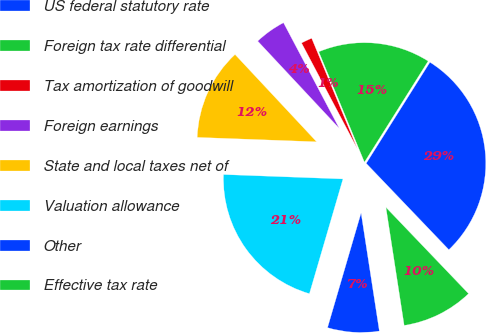Convert chart to OTSL. <chart><loc_0><loc_0><loc_500><loc_500><pie_chart><fcel>US federal statutory rate<fcel>Foreign tax rate differential<fcel>Tax amortization of goodwill<fcel>Foreign earnings<fcel>State and local taxes net of<fcel>Valuation allowance<fcel>Other<fcel>Effective tax rate<nl><fcel>28.9%<fcel>15.19%<fcel>1.49%<fcel>4.23%<fcel>12.45%<fcel>21.06%<fcel>6.97%<fcel>9.71%<nl></chart> 